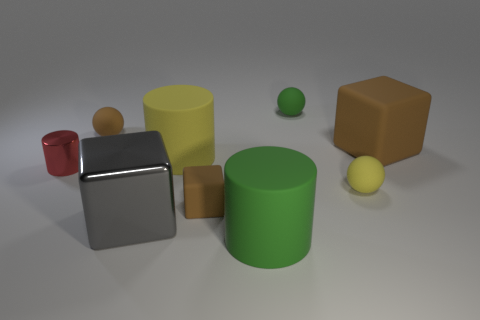There is a brown rubber cube in front of the metallic cylinder; how many small green matte objects are to the left of it?
Ensure brevity in your answer.  0. Is the number of big blocks in front of the small yellow thing less than the number of tiny purple shiny spheres?
Offer a terse response. No. There is a tiny brown matte thing behind the brown matte thing on the right side of the big cylinder in front of the tiny yellow thing; what shape is it?
Ensure brevity in your answer.  Sphere. Do the gray object and the large yellow object have the same shape?
Give a very brief answer. No. What number of other objects are there of the same shape as the large green rubber object?
Your answer should be very brief. 2. The matte block that is the same size as the yellow sphere is what color?
Your response must be concise. Brown. Is the number of brown matte balls behind the yellow rubber ball the same as the number of cylinders?
Your response must be concise. No. What is the shape of the brown thing that is both behind the red object and in front of the tiny brown sphere?
Provide a short and direct response. Cube. Do the gray cube and the brown sphere have the same size?
Provide a succinct answer. No. Is there a brown cube that has the same material as the green cylinder?
Provide a succinct answer. Yes. 